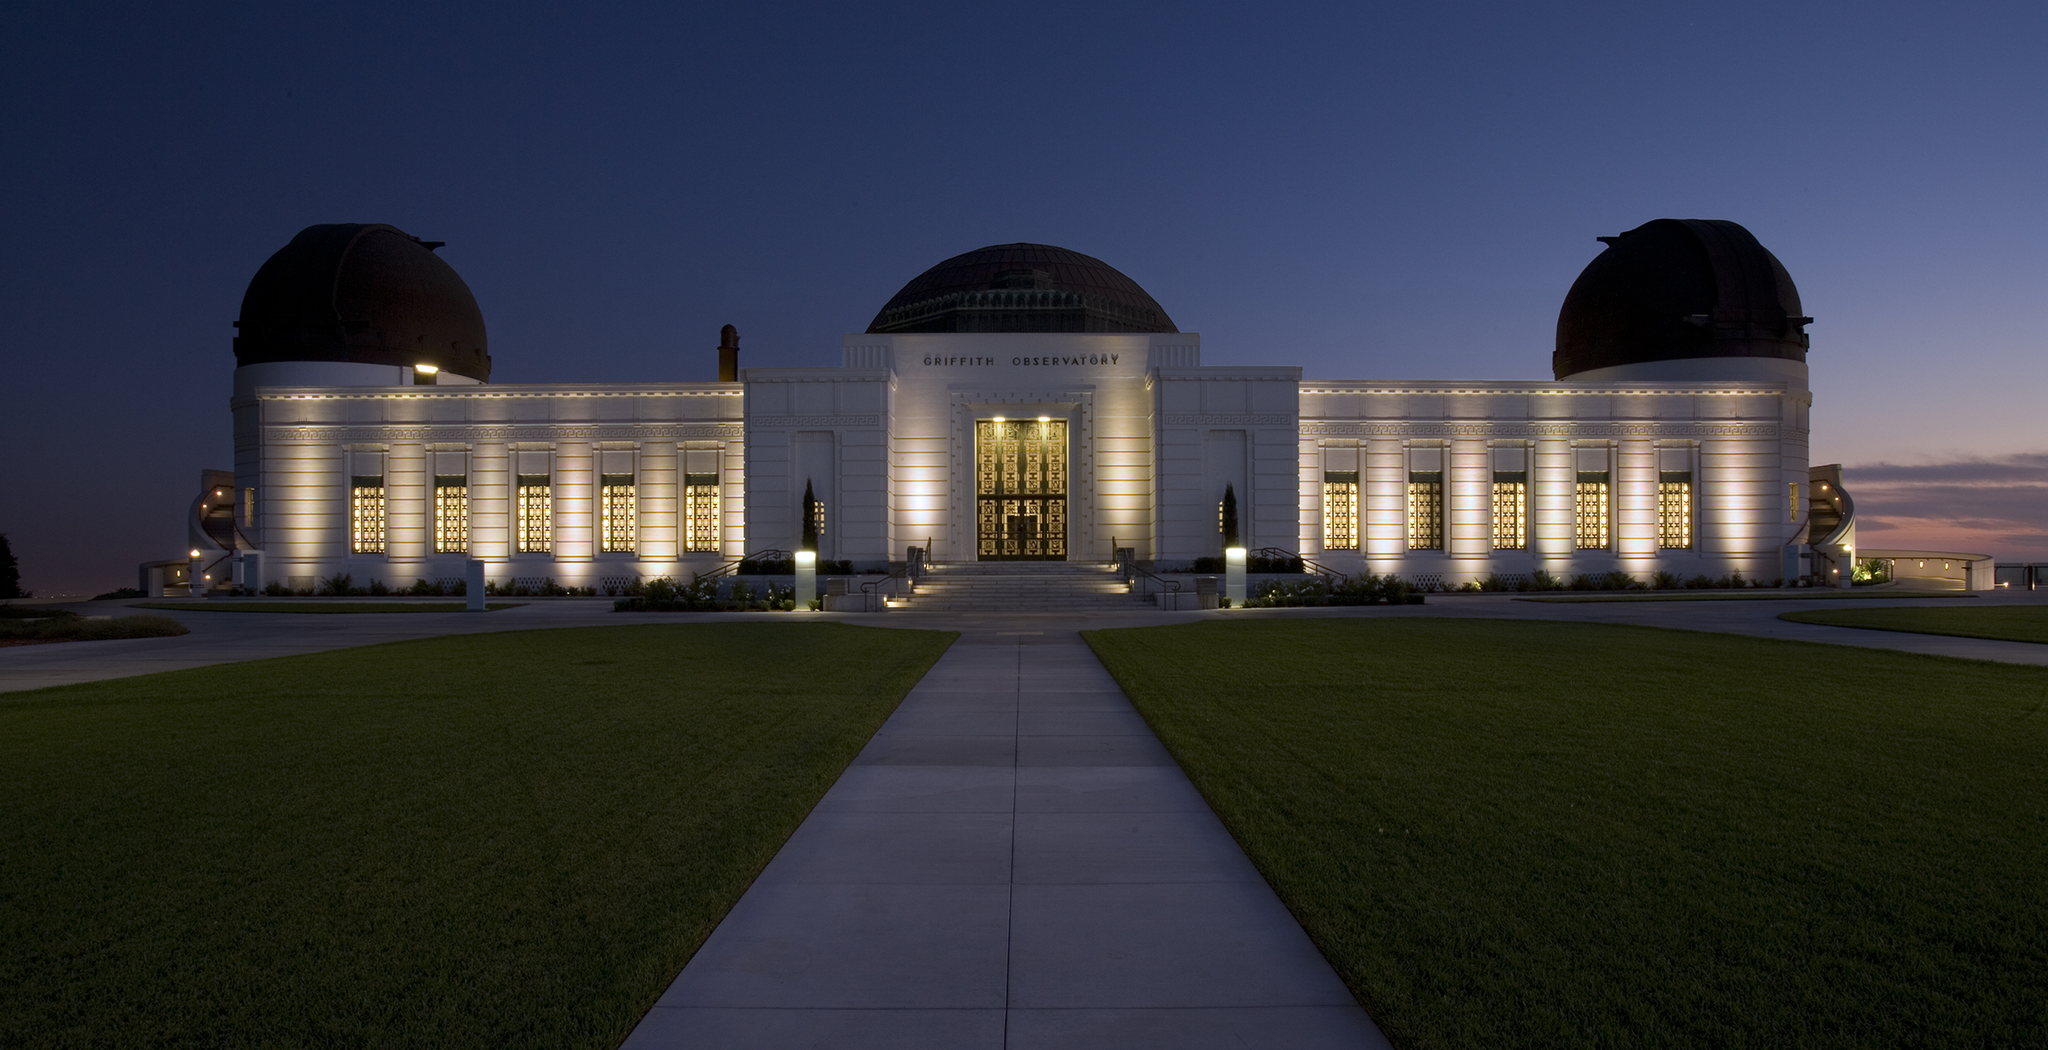What do you think is the history of this observatory? Griffith Observatory, an iconic institution, was inaugurated in 1935, thanks to the vision and generosity of Griffith J. Griffith. It was built with the notion that astronomy should be accessible to everyone, reflecting this through free public services. Over the decades, it has witnessed numerous advancements in scientific understanding and technology, hosting countless educational programs, exhibits, and public viewings of celestial events. The observatory has not only served as a center for scientific learning but also as a cultural landmark, appearing in various films and works of art. Its rich history is intertwined with the development of Los Angeles itself, standing as a beacon of knowledge and inspiration for millions of visitors from around the world. 